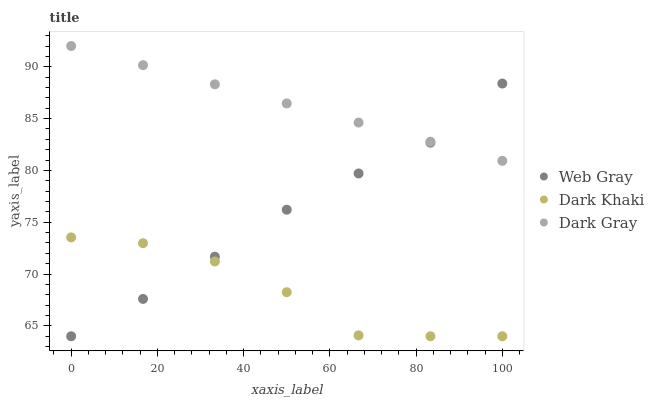Does Dark Khaki have the minimum area under the curve?
Answer yes or no. Yes. Does Dark Gray have the maximum area under the curve?
Answer yes or no. Yes. Does Web Gray have the minimum area under the curve?
Answer yes or no. No. Does Web Gray have the maximum area under the curve?
Answer yes or no. No. Is Dark Gray the smoothest?
Answer yes or no. Yes. Is Dark Khaki the roughest?
Answer yes or no. Yes. Is Web Gray the smoothest?
Answer yes or no. No. Is Web Gray the roughest?
Answer yes or no. No. Does Dark Khaki have the lowest value?
Answer yes or no. Yes. Does Dark Gray have the lowest value?
Answer yes or no. No. Does Dark Gray have the highest value?
Answer yes or no. Yes. Does Web Gray have the highest value?
Answer yes or no. No. Is Dark Khaki less than Dark Gray?
Answer yes or no. Yes. Is Dark Gray greater than Dark Khaki?
Answer yes or no. Yes. Does Web Gray intersect Dark Khaki?
Answer yes or no. Yes. Is Web Gray less than Dark Khaki?
Answer yes or no. No. Is Web Gray greater than Dark Khaki?
Answer yes or no. No. Does Dark Khaki intersect Dark Gray?
Answer yes or no. No. 